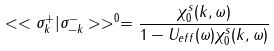<formula> <loc_0><loc_0><loc_500><loc_500>< < \sigma ^ { + } _ { k } | \sigma ^ { - } _ { - k } > > ^ { 0 } = \frac { \chi ^ { s } _ { 0 } ( k , \omega ) } { 1 - U _ { e f f } ( \omega ) \chi ^ { s } _ { 0 } ( k , \omega ) }</formula> 